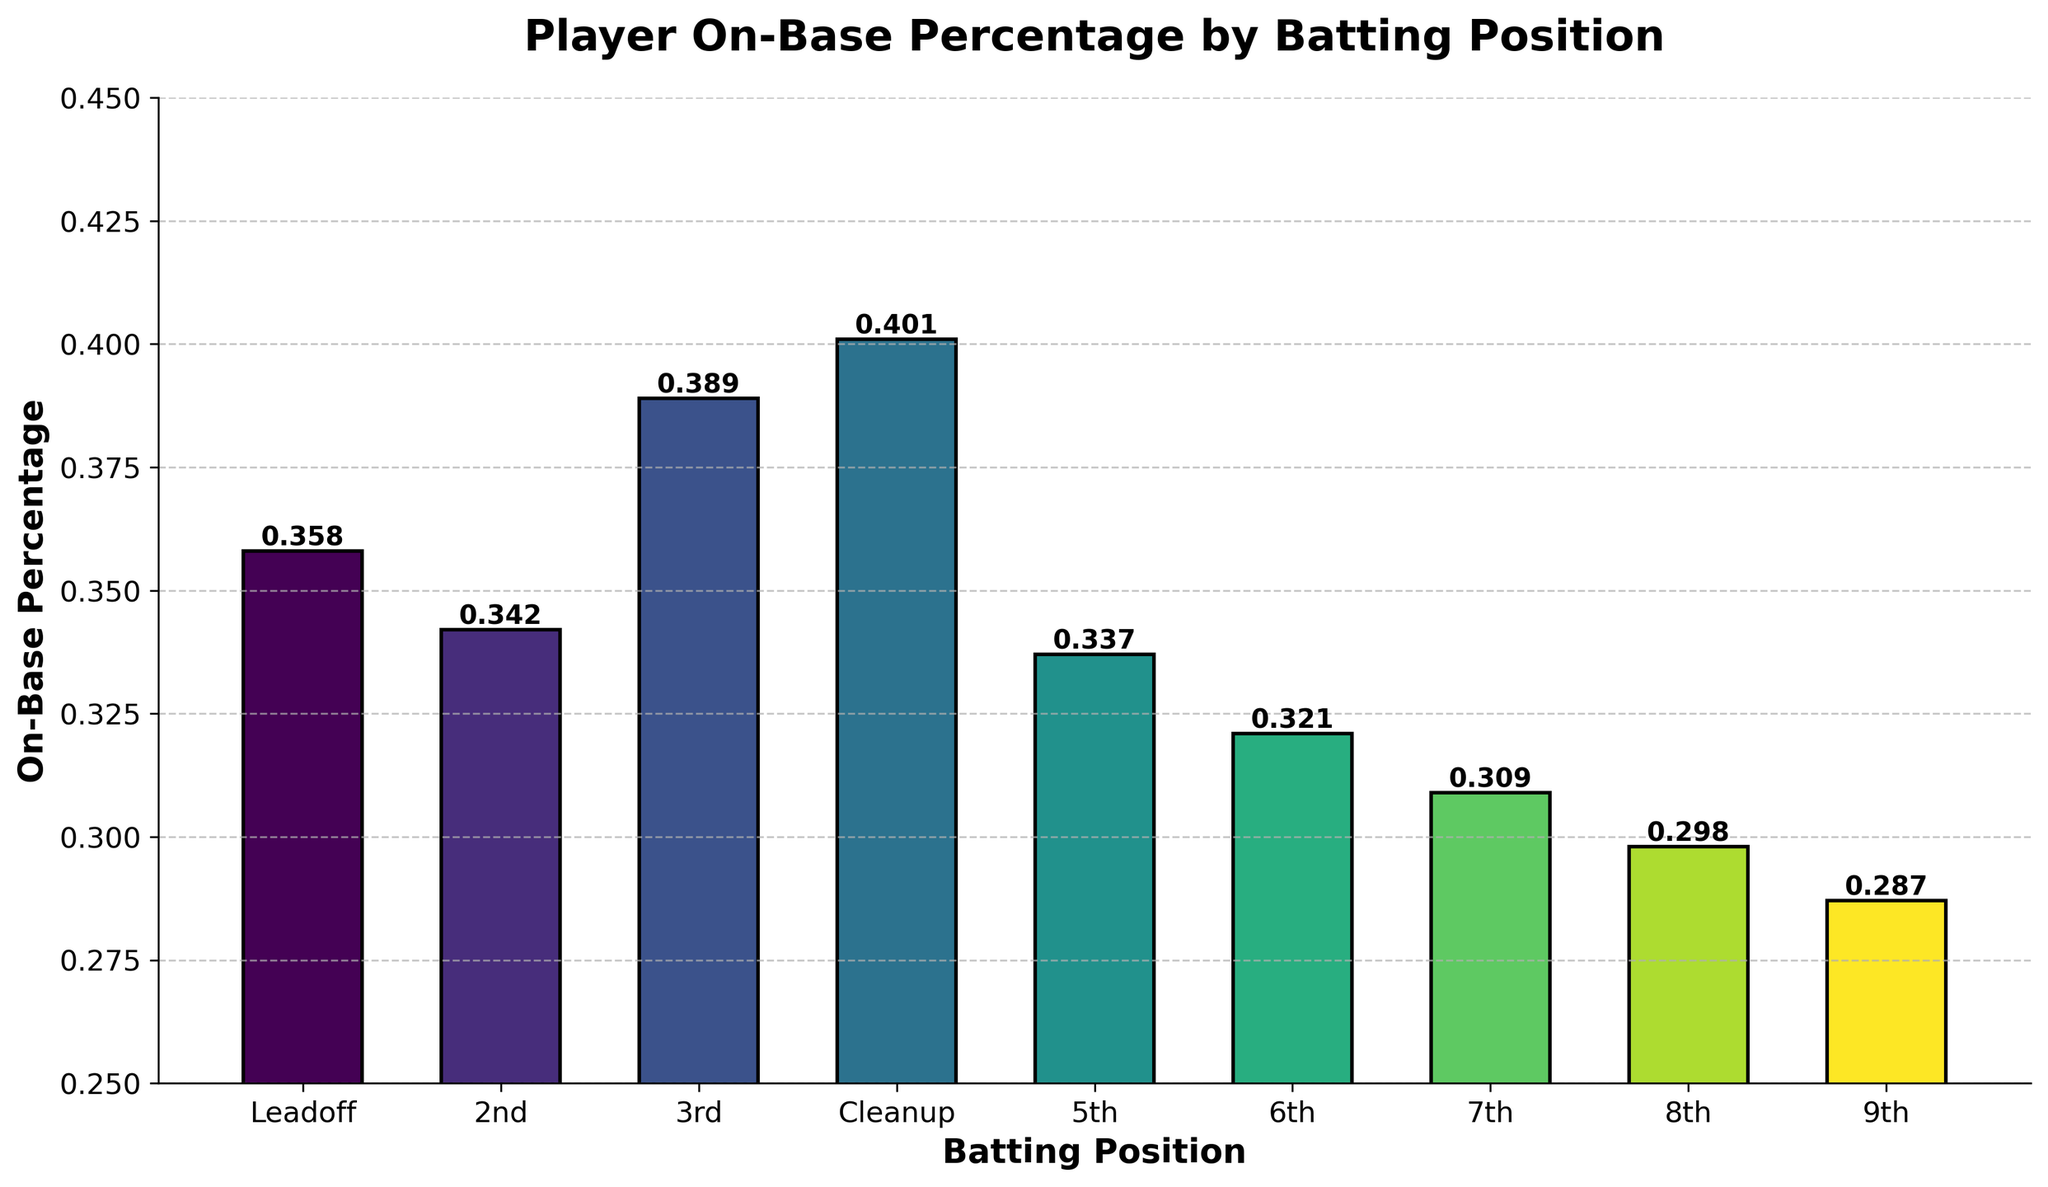What's the on-base percentage for the Cleanup position? Identify the bar labeled 'Cleanup' and read its height, which is the on-base percentage for that position.
Answer: 0.401 Which batting position has the lowest on-base percentage? Look for the shortest bar in the chart; it corresponds to the 9th batting position.
Answer: 9th What is the difference in on-base percentage between the 3rd and 5th batting positions? Find the height of the bars for the 3rd (0.389) and 5th (0.337) positions and subtract the smaller value from the larger value: 0.389 - 0.337 = 0.052.
Answer: 0.052 Which batting position has a higher on-base percentage, the Leadoff or the 2nd position? Compare the heights of the bars for the Leadoff (0.358) and 2nd (0.342) positions. The Leadoff position has a higher value.
Answer: Leadoff What is the combined on-base percentage for the Cleanup and 2nd positions? Add the heights of the bars for the Cleanup (0.401) and 2nd (0.342) positions: 0.401 + 0.342 = 0.743.
Answer: 0.743 Which two batting positions have on-base percentages greater than 0.35? Look for bars with heights greater than 0.35; these correspond to the Cleanup (0.401) and Leadoff (0.358) positions.
Answer: Cleanup and Leadoff What is the average on-base percentage for the 6th, 7th, and 8th positions? Add the heights of the bars for the 6th (0.321), 7th (0.309), and 8th (0.298) positions: 0.321 + 0.309 + 0.298 = 0.928. Then divide by 3: 0.928 / 3 ≈ 0.309.
Answer: 0.309 Which batting position is the most visually distinguishable in terms of bar color? Identify the bar with the most distinct color from others, likely the Cleanup position, which appears in a brighter shade.
Answer: Cleanup How many batting positions have an on-base percentage greater than 0.36? Count the bars with heights above 0.36: Cleanup (0.401) and 3rd (0.389).
Answer: 2 